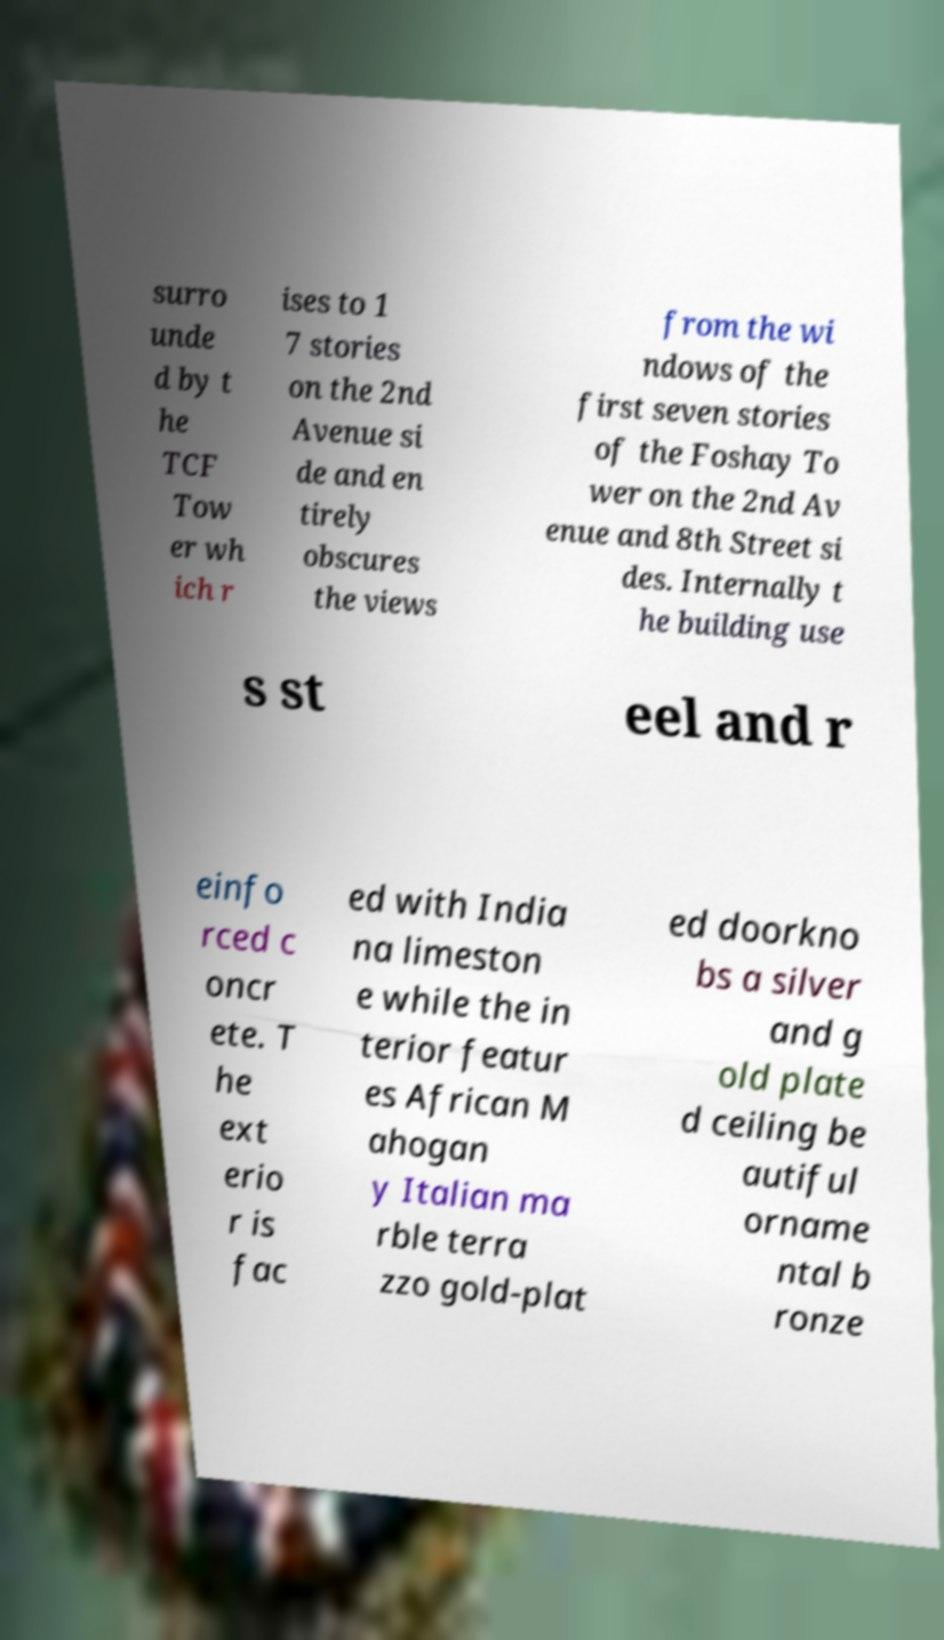Could you assist in decoding the text presented in this image and type it out clearly? surro unde d by t he TCF Tow er wh ich r ises to 1 7 stories on the 2nd Avenue si de and en tirely obscures the views from the wi ndows of the first seven stories of the Foshay To wer on the 2nd Av enue and 8th Street si des. Internally t he building use s st eel and r einfo rced c oncr ete. T he ext erio r is fac ed with India na limeston e while the in terior featur es African M ahogan y Italian ma rble terra zzo gold-plat ed doorkno bs a silver and g old plate d ceiling be autiful orname ntal b ronze 